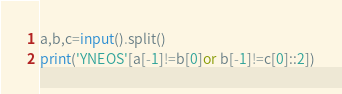<code> <loc_0><loc_0><loc_500><loc_500><_Python_>a,b,c=input().split()
print('YNEOS'[a[-1]!=b[0]or b[-1]!=c[0]::2])</code> 